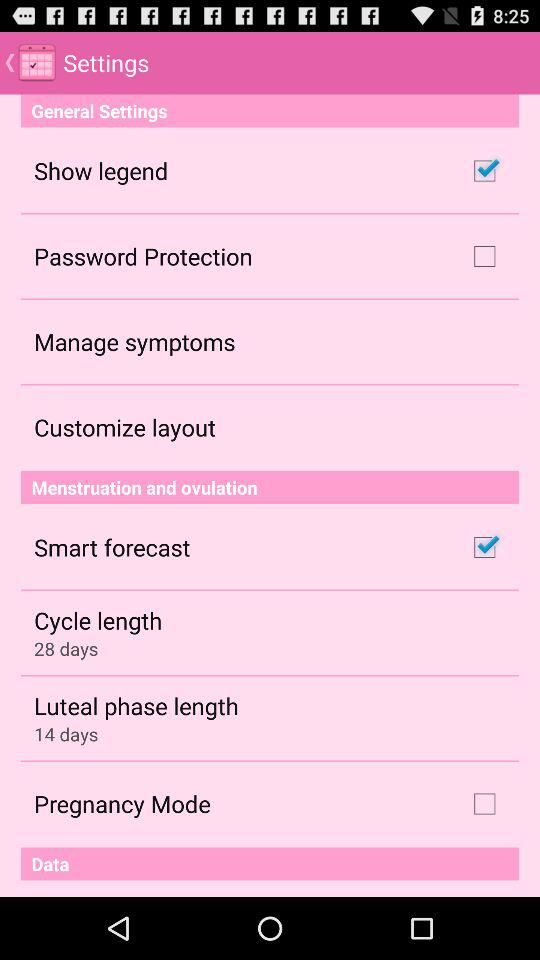What is the status of the "Show legend"? The status of the "Show legend" is "on". 